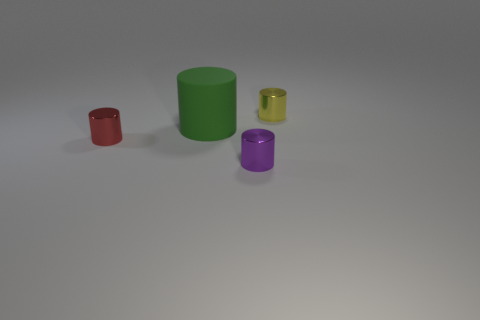Add 1 brown rubber cylinders. How many objects exist? 5 Add 1 brown matte things. How many brown matte things exist? 1 Subtract 0 brown cylinders. How many objects are left? 4 Subtract all red shiny blocks. Subtract all small purple metallic things. How many objects are left? 3 Add 1 matte objects. How many matte objects are left? 2 